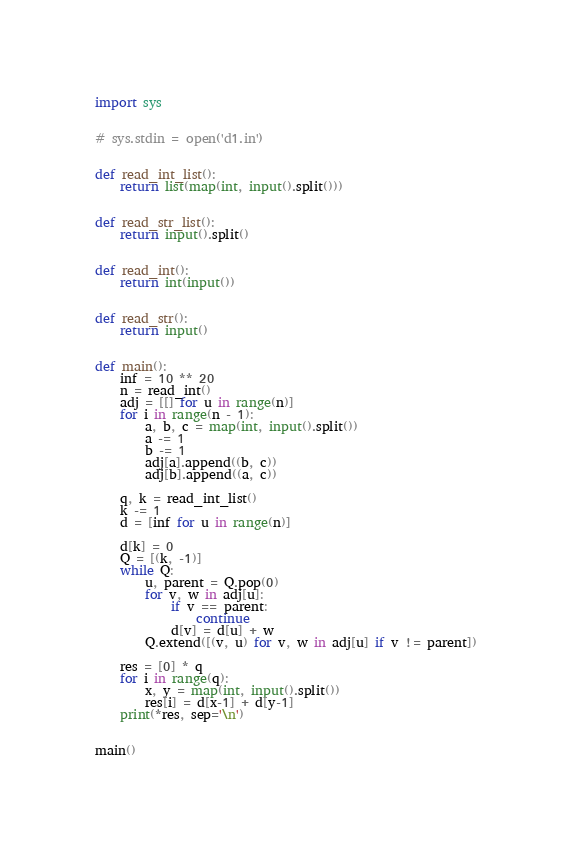<code> <loc_0><loc_0><loc_500><loc_500><_Python_>import sys


# sys.stdin = open('d1.in')


def read_int_list():
    return list(map(int, input().split()))


def read_str_list():
    return input().split()


def read_int():
    return int(input())


def read_str():
    return input()


def main():
    inf = 10 ** 20
    n = read_int()
    adj = [[] for u in range(n)]
    for i in range(n - 1):
        a, b, c = map(int, input().split())
        a -= 1
        b -= 1
        adj[a].append((b, c))
        adj[b].append((a, c))

    q, k = read_int_list()
    k -= 1
    d = [inf for u in range(n)]

    d[k] = 0
    Q = [(k, -1)]
    while Q:
        u, parent = Q.pop(0)
        for v, w in adj[u]:
            if v == parent:
                continue
            d[v] = d[u] + w
        Q.extend([(v, u) for v, w in adj[u] if v != parent])

    res = [0] * q
    for i in range(q):
        x, y = map(int, input().split())
        res[i] = d[x-1] + d[y-1]
    print(*res, sep='\n')


main()
</code> 